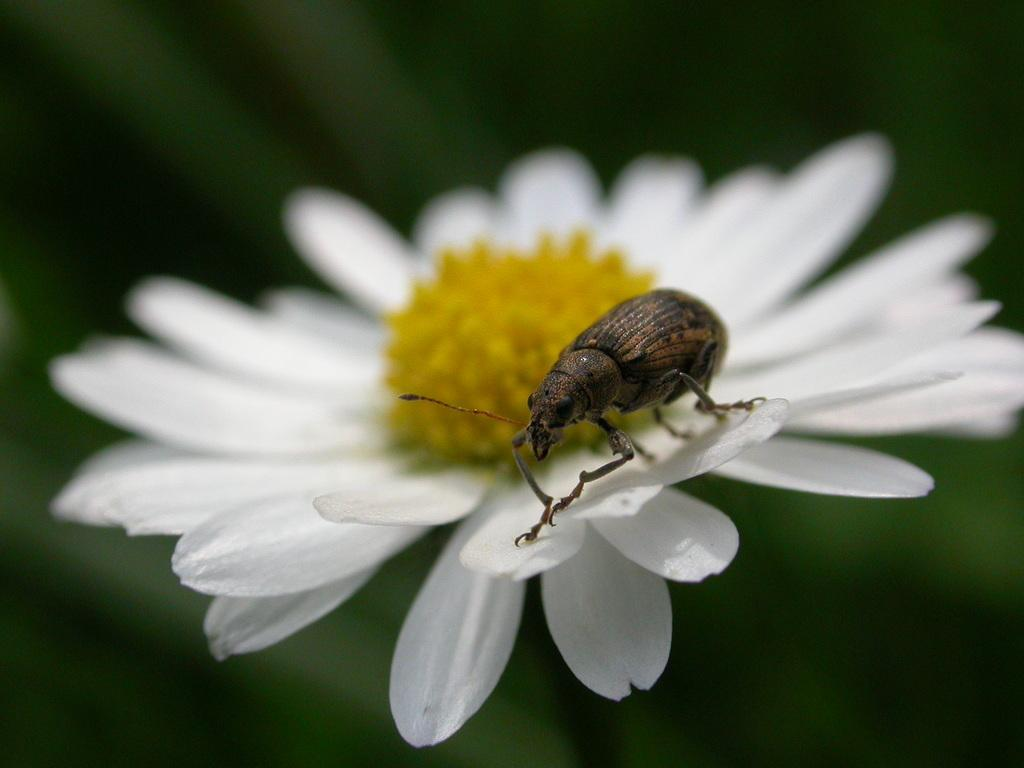What is the main subject in the center of the image? There is a flower and a beetle in the center of the image. Can you describe the appearance of the flower? Unfortunately, the facts provided do not give a detailed description of the flower. How is the background of the image depicted? The background of the image is blurred. What type of environment is suggested by the greenery in the background? The greenery in the background suggests a natural or outdoor environment. What type of jam is being spread on the bread in the image? There is no bread or jam present in the image; it features a flower and a beetle in the center, with a blurred background and greenery. 